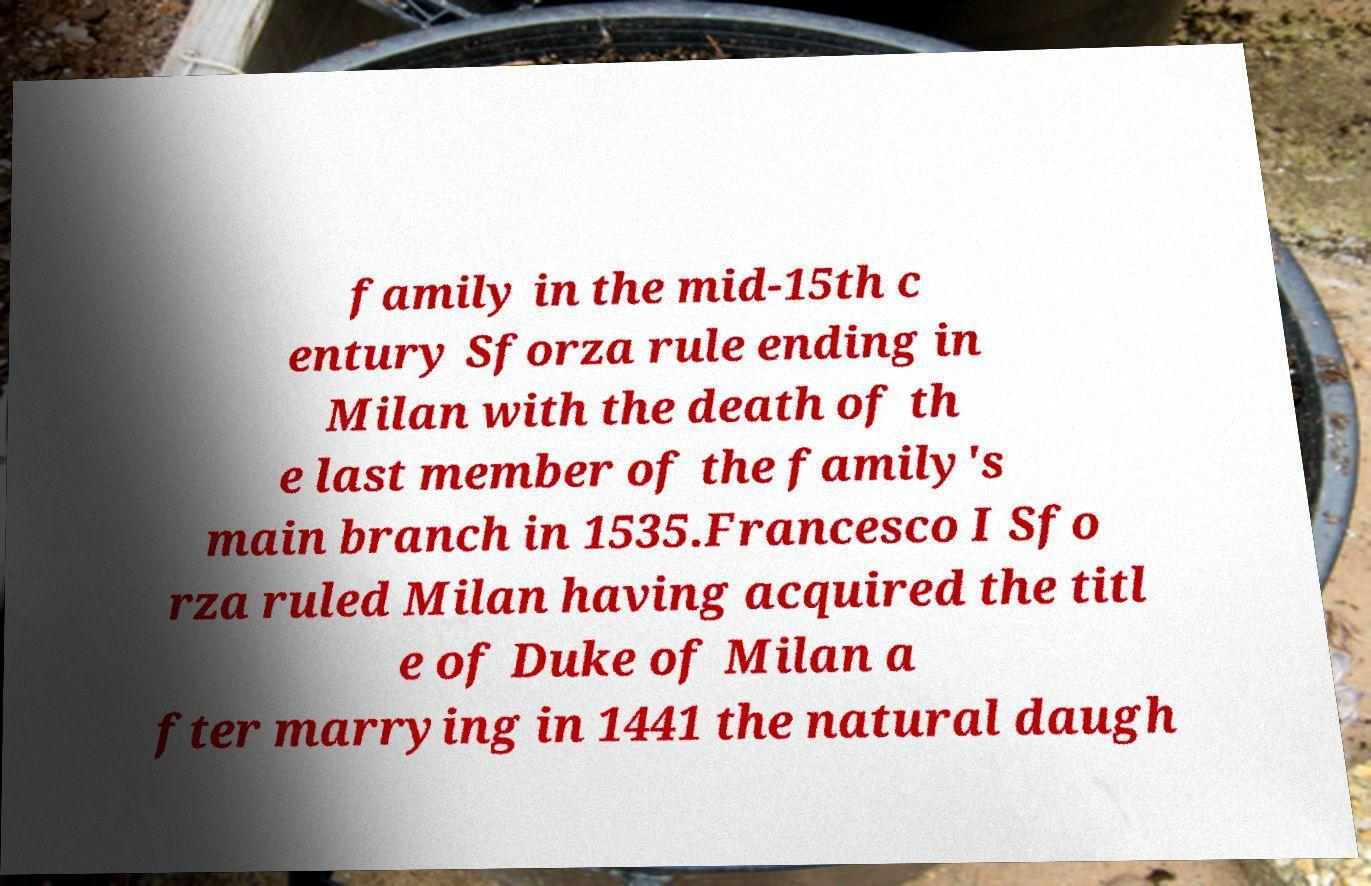Please read and relay the text visible in this image. What does it say? family in the mid-15th c entury Sforza rule ending in Milan with the death of th e last member of the family's main branch in 1535.Francesco I Sfo rza ruled Milan having acquired the titl e of Duke of Milan a fter marrying in 1441 the natural daugh 